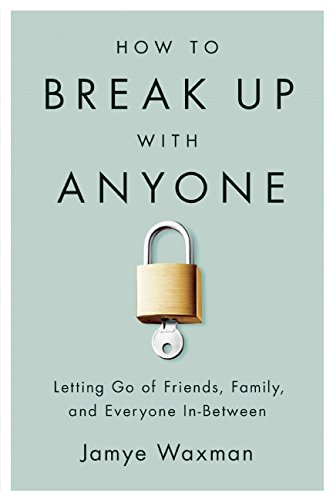Is this a religious book? No, this book is not religious in nature; it focuses purely on personal relationships and self-improvement without any religious context. 